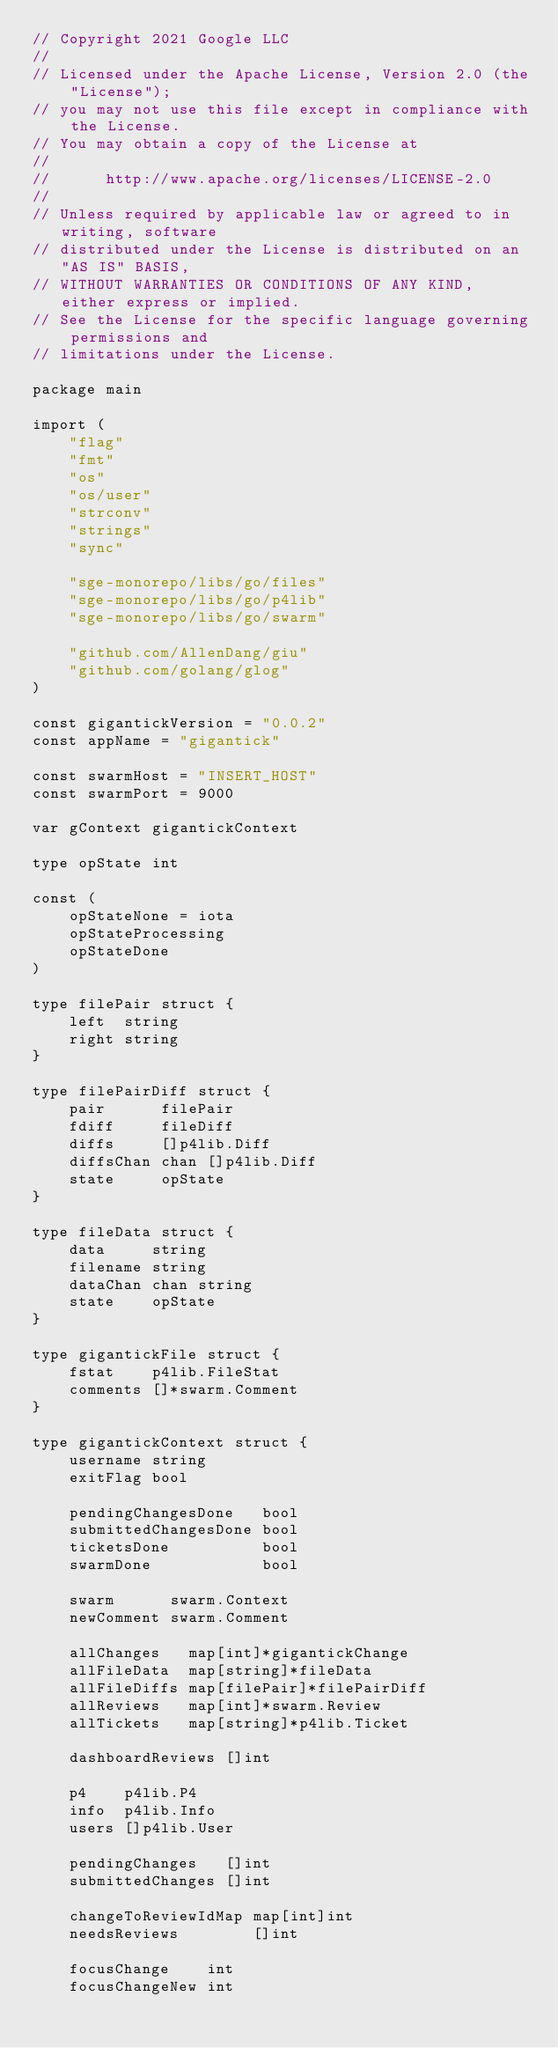Convert code to text. <code><loc_0><loc_0><loc_500><loc_500><_Go_>// Copyright 2021 Google LLC
//
// Licensed under the Apache License, Version 2.0 (the "License");
// you may not use this file except in compliance with the License.
// You may obtain a copy of the License at
//
//      http://www.apache.org/licenses/LICENSE-2.0
//
// Unless required by applicable law or agreed to in writing, software
// distributed under the License is distributed on an "AS IS" BASIS,
// WITHOUT WARRANTIES OR CONDITIONS OF ANY KIND, either express or implied.
// See the License for the specific language governing permissions and
// limitations under the License.

package main

import (
	"flag"
	"fmt"
	"os"
	"os/user"
	"strconv"
	"strings"
	"sync"

	"sge-monorepo/libs/go/files"
	"sge-monorepo/libs/go/p4lib"
	"sge-monorepo/libs/go/swarm"

	"github.com/AllenDang/giu"
	"github.com/golang/glog"
)

const gigantickVersion = "0.0.2"
const appName = "gigantick"

const swarmHost = "INSERT_HOST"
const swarmPort = 9000

var gContext gigantickContext

type opState int

const (
	opStateNone = iota
	opStateProcessing
	opStateDone
)

type filePair struct {
	left  string
	right string
}

type filePairDiff struct {
	pair      filePair
	fdiff     fileDiff
	diffs     []p4lib.Diff
	diffsChan chan []p4lib.Diff
	state     opState
}

type fileData struct {
	data     string
	filename string
	dataChan chan string
	state    opState
}

type gigantickFile struct {
	fstat    p4lib.FileStat
	comments []*swarm.Comment
}

type gigantickContext struct {
	username string
	exitFlag bool

	pendingChangesDone   bool
	submittedChangesDone bool
	ticketsDone          bool
	swarmDone            bool

	swarm      swarm.Context
	newComment swarm.Comment

	allChanges   map[int]*gigantickChange
	allFileData  map[string]*fileData
	allFileDiffs map[filePair]*filePairDiff
	allReviews   map[int]*swarm.Review
	allTickets   map[string]*p4lib.Ticket

	dashboardReviews []int

	p4    p4lib.P4
	info  p4lib.Info
	users []p4lib.User

	pendingChanges   []int
	submittedChanges []int

	changeToReviewIdMap map[int]int
	needsReviews        []int

	focusChange    int
	focusChangeNew int</code> 